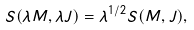Convert formula to latex. <formula><loc_0><loc_0><loc_500><loc_500>S ( \lambda M , \lambda J ) = \lambda ^ { 1 / 2 } S ( M , J ) ,</formula> 